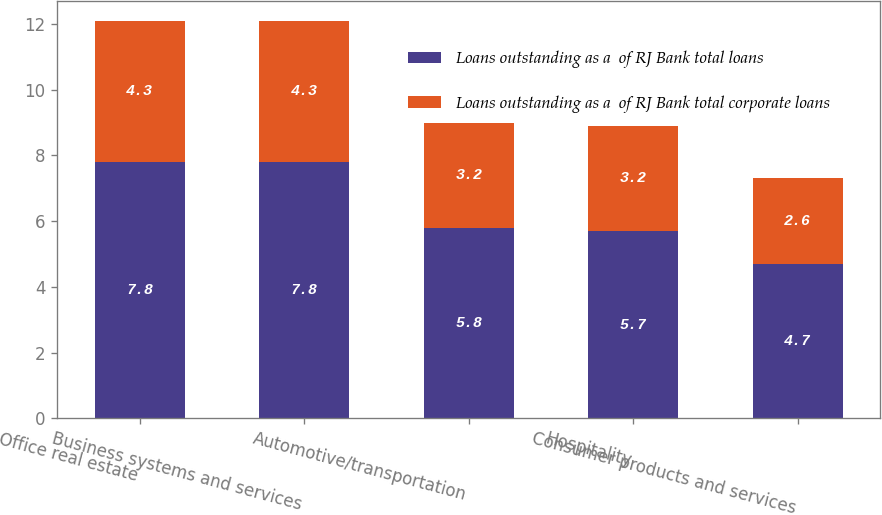Convert chart to OTSL. <chart><loc_0><loc_0><loc_500><loc_500><stacked_bar_chart><ecel><fcel>Office real estate<fcel>Business systems and services<fcel>Automotive/transportation<fcel>Hospitality<fcel>Consumer products and services<nl><fcel>Loans outstanding as a  of RJ Bank total loans<fcel>7.8<fcel>7.8<fcel>5.8<fcel>5.7<fcel>4.7<nl><fcel>Loans outstanding as a  of RJ Bank total corporate loans<fcel>4.3<fcel>4.3<fcel>3.2<fcel>3.2<fcel>2.6<nl></chart> 